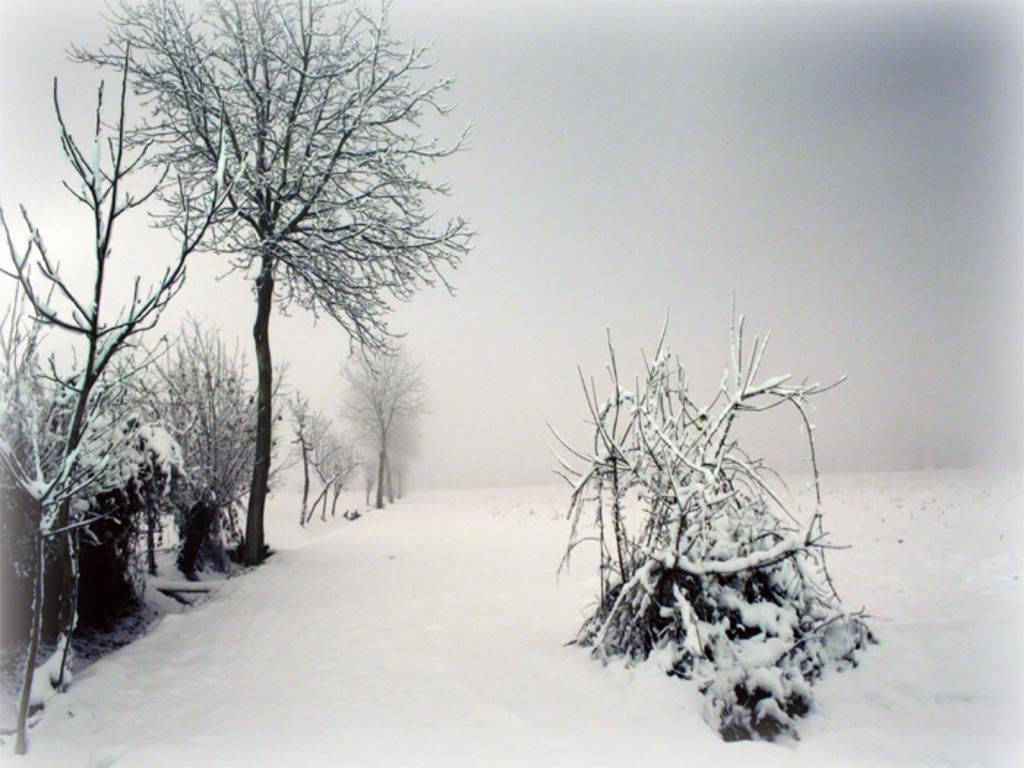What type of vegetation can be seen in the image? There are trees in the image. What is covering the trees in the image? The trees are covered with snow. What is present on the ground in the image? There is snow on the floor. Where is the drawer located in the image? There is no drawer present in the image; it features trees covered with snow and snow on the ground. 